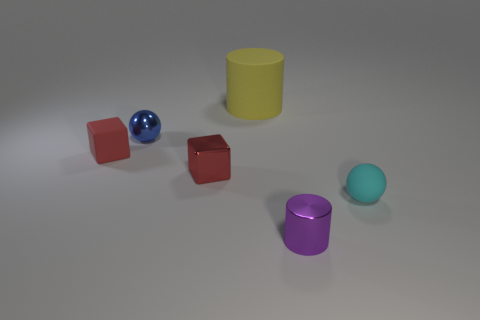Is the number of tiny red metallic objects that are behind the purple shiny cylinder less than the number of cyan metallic objects? Upon closer inspection of the image, it appears there is one tiny red metallic cube, whereas there is only one cyan metallic sphere present. So the number of red metallic objects is equal to, not less than, the number of cyan metallic objects. 